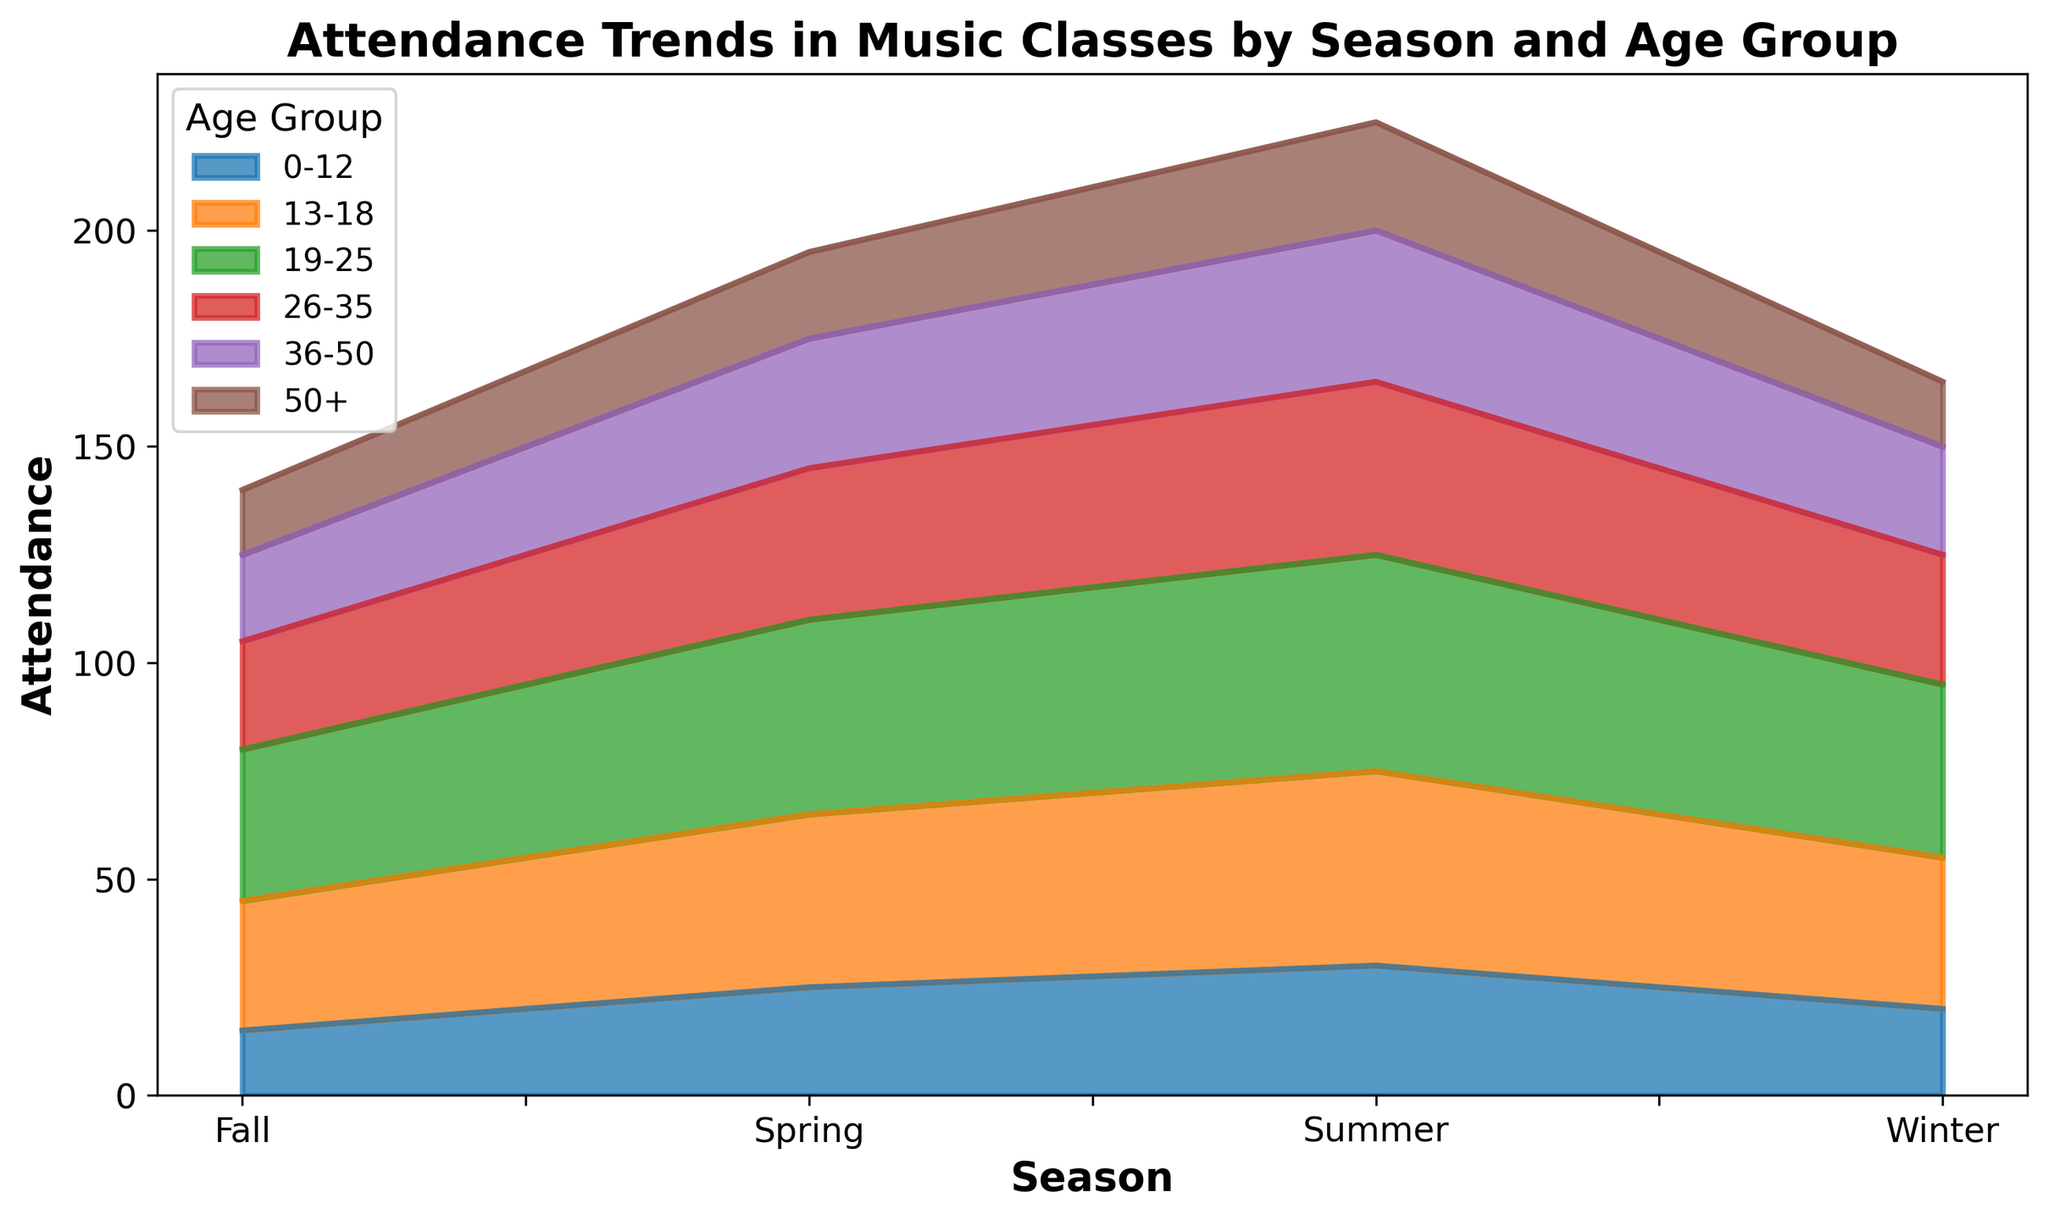What is the total attendance in the Summer? To find the total attendance for Summer, sum the attendance values for each age group in the Summer season: 30 (0-12) + 45 (13-18) + 50 (19-25) + 40 (26-35) + 35 (36-50) + 25 (50+). This yields a sum of 225.
Answer: 225 Which age group has the highest attendance in Spring? Look at the Spring season segment on the chart and identify the tallest segment. The age group with the highest attendance in Spring is the 19-25 group which has an attendance of 45.
Answer: 19-25 How does the attendance of the 13-18 age group in Winter compare to that in Fall? The attendance of the 13-18 age group in Winter is 35, whereas in Fall it’s 30. This shows a decrease when moving from Winter to Fall.
Answer: Decreases Which season has the lowest total attendance for the 50+ age group? To find the season with the lowest attendance for the 50+ age group, compare the attendance values across each season for the 50+ age group. Winter has an attendance of 15, Spring has 20, Summer has 25, and Fall also has 15. Both Winter and Fall have the lowest with an attendance of 15.
Answer: Winter and Fall What is the average attendance for the 26-35 age group across all seasons? To get the average attendance for the 26-35 age group, sum the attendance numbers across all seasons: 30 (Winter) + 35 (Spring) + 40 (Summer) + 25 (Fall) = 130. Then divide by the number of seasons (4). 130 / 4 = 32.5
Answer: 32.5 Which age group saw the biggest increase in attendance from Fall to Winter? To find the biggest increase, subtract the Fall attendance from the Winter attendance for each age group and identify the largest positive difference. (0-12: 20-15=5), (13-18: 35-30=5), (19-25: 40-35=5), (26-35: 30-25=5), (36-50: 25-20=5), (50+: 15-15=0). The increase is the same (5) for all age groups except 50+.
Answer: 0-12, 13-18, 19-25, 26-35, 36-50 By how much does total attendance increase from Winter to Spring? Sum the attendance for each age group in Winter and in Spring, then subtract the Winter total from the Spring total: Winter total = 20 + 35 + 40 + 30 + 25 + 15 = 165, Spring total = 25 + 40 + 45 + 35 + 30 + 20 = 195. Therefore, increase is 195 - 165 = 30.
Answer: 30 In which season does the 0-12 age group see its highest attendance? Look at each segment corresponding to the 0-12 age group and identify the season with the highest value. The 0-12 age group has the highest attendance in Summer, with an attendance of 30.
Answer: Summer Which season shows the biggest contrast between the attendance of the youngest (0-12) and the oldest (50+) age groups? Calculate the difference between the attendance of the 0-12 and 50+ age groups for each season and identify the highest difference. Winter: 20-15=5, Spring: 25-20=5, Summer: 30-25=5, Fall: 15-15=0. The biggest contrast is the same (5) for all but Fall.
Answer: Winter, Spring, Summer What is the total attendance across all seasons and age groups? Calculate the total attendance by summing all attendance values in the dataset. 20+35+40+30+25+15 + 25+40+45+35+30+20 + 30+45+50+40+35+25 + 15+30+35+25+20+15 = 695.
Answer: 695 